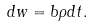<formula> <loc_0><loc_0><loc_500><loc_500>d w = b \rho d t .</formula> 